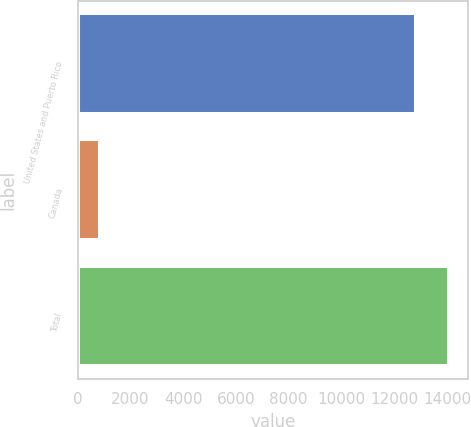<chart> <loc_0><loc_0><loc_500><loc_500><bar_chart><fcel>United States and Puerto Rico<fcel>Canada<fcel>Total<nl><fcel>12812<fcel>837<fcel>14093.2<nl></chart> 